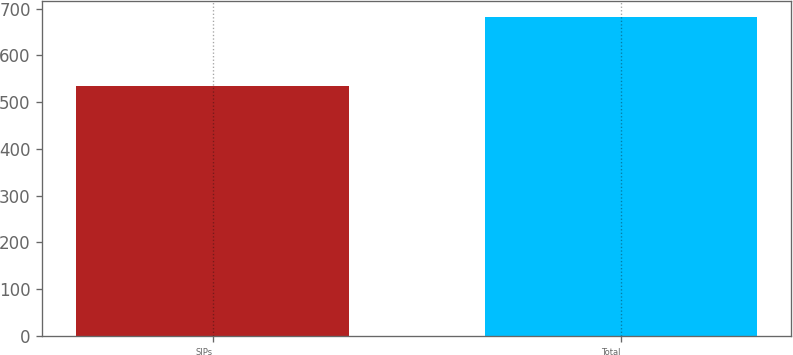Convert chart. <chart><loc_0><loc_0><loc_500><loc_500><bar_chart><fcel>SIPs<fcel>Total<nl><fcel>534.6<fcel>682.2<nl></chart> 